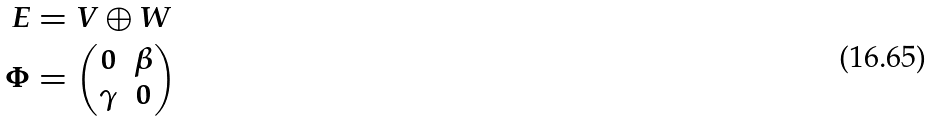<formula> <loc_0><loc_0><loc_500><loc_500>E & = V \oplus W \\ \Phi & = \left ( \begin{matrix} 0 & \beta \\ \gamma & 0 \end{matrix} \right )</formula> 